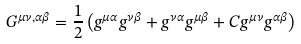<formula> <loc_0><loc_0><loc_500><loc_500>G ^ { \mu \nu , \alpha \beta } = \frac { 1 } { 2 } \left ( g ^ { \mu \alpha } g ^ { \nu \beta } + g ^ { \nu \alpha } g ^ { \mu \beta } + C g ^ { \mu \nu } g ^ { \alpha \beta } \right )</formula> 